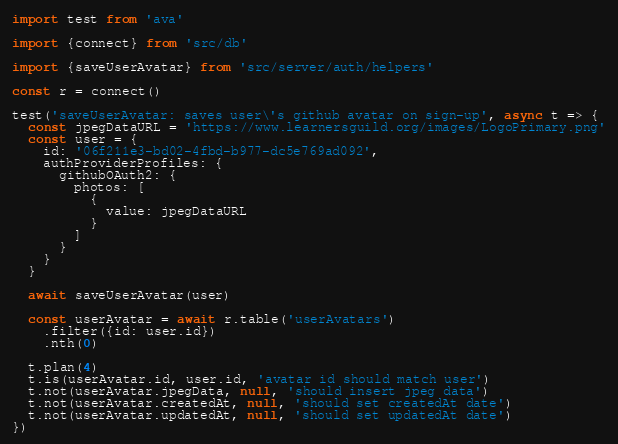Convert code to text. <code><loc_0><loc_0><loc_500><loc_500><_JavaScript_>import test from 'ava'

import {connect} from 'src/db'

import {saveUserAvatar} from 'src/server/auth/helpers'

const r = connect()

test('saveUserAvatar: saves user\'s github avatar on sign-up', async t => {
  const jpegDataURL = 'https://www.learnersguild.org/images/LogoPrimary.png'
  const user = {
    id: '06f211e3-bd02-4fbd-b977-dc5e769ad092',
    authProviderProfiles: {
      githubOAuth2: {
        photos: [
          {
            value: jpegDataURL
          }
        ]
      }
    }
  }

  await saveUserAvatar(user)

  const userAvatar = await r.table('userAvatars')
    .filter({id: user.id})
    .nth(0)

  t.plan(4)
  t.is(userAvatar.id, user.id, 'avatar id should match user')
  t.not(userAvatar.jpegData, null, 'should insert jpeg data')
  t.not(userAvatar.createdAt, null, 'should set createdAt date')
  t.not(userAvatar.updatedAt, null, 'should set updatedAt date')
})
</code> 